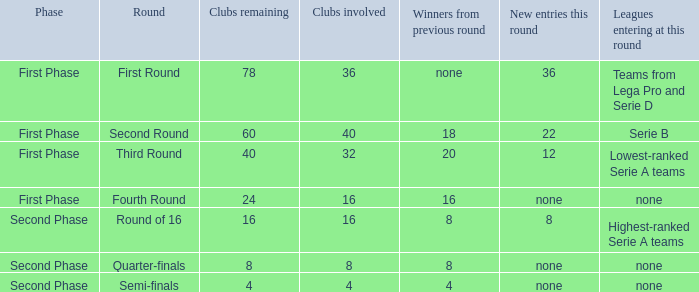Can you parse all the data within this table? {'header': ['Phase', 'Round', 'Clubs remaining', 'Clubs involved', 'Winners from previous round', 'New entries this round', 'Leagues entering at this round'], 'rows': [['First Phase', 'First Round', '78', '36', 'none', '36', 'Teams from Lega Pro and Serie D'], ['First Phase', 'Second Round', '60', '40', '18', '22', 'Serie B'], ['First Phase', 'Third Round', '40', '32', '20', '12', 'Lowest-ranked Serie A teams'], ['First Phase', 'Fourth Round', '24', '16', '16', 'none', 'none'], ['Second Phase', 'Round of 16', '16', '16', '8', '8', 'Highest-ranked Serie A teams'], ['Second Phase', 'Quarter-finals', '8', '8', '8', 'none', 'none'], ['Second Phase', 'Semi-finals', '4', '4', '4', 'none', 'none']]} Considering 8 clubs are taking part, what numerical value can be obtained from the winners in the last round? 8.0. 